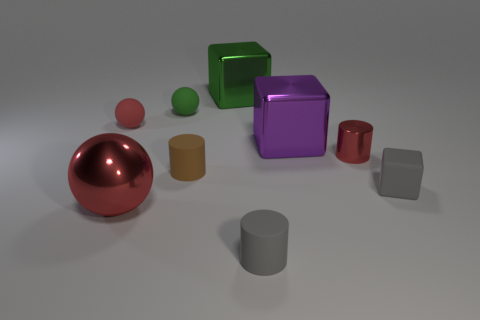Subtract all green matte spheres. How many spheres are left? 2 Subtract all red spheres. How many spheres are left? 1 Subtract 2 cylinders. How many cylinders are left? 1 Subtract all balls. How many objects are left? 6 Add 7 rubber blocks. How many rubber blocks are left? 8 Add 2 metallic cylinders. How many metallic cylinders exist? 3 Subtract 1 red balls. How many objects are left? 8 Subtract all yellow balls. Subtract all cyan blocks. How many balls are left? 3 Subtract all cyan cylinders. How many green spheres are left? 1 Subtract all small purple matte balls. Subtract all small cylinders. How many objects are left? 6 